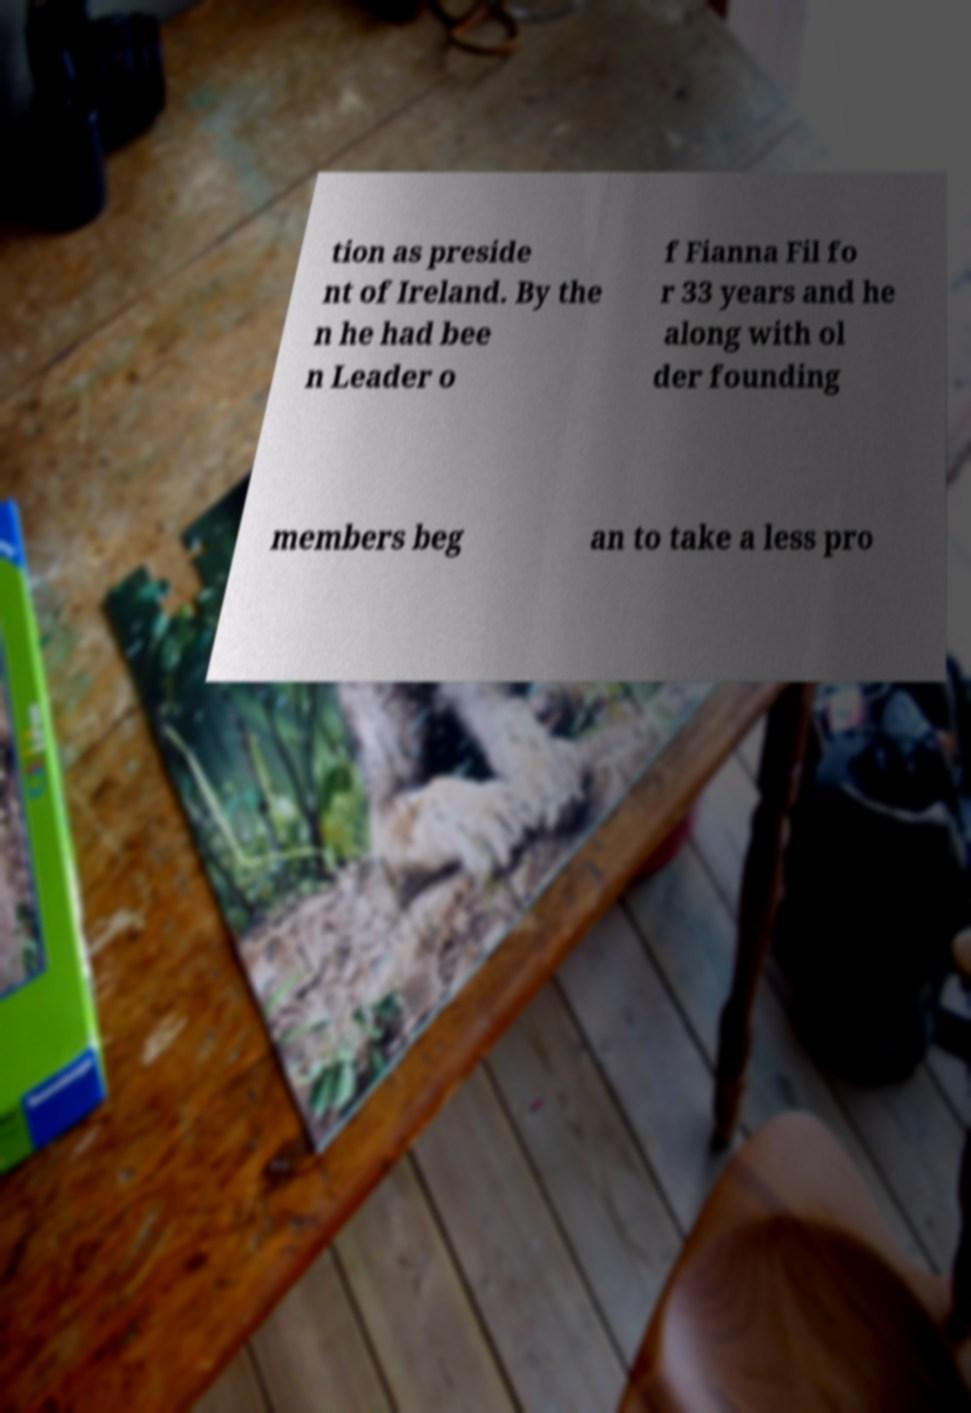What messages or text are displayed in this image? I need them in a readable, typed format. tion as preside nt of Ireland. By the n he had bee n Leader o f Fianna Fil fo r 33 years and he along with ol der founding members beg an to take a less pro 